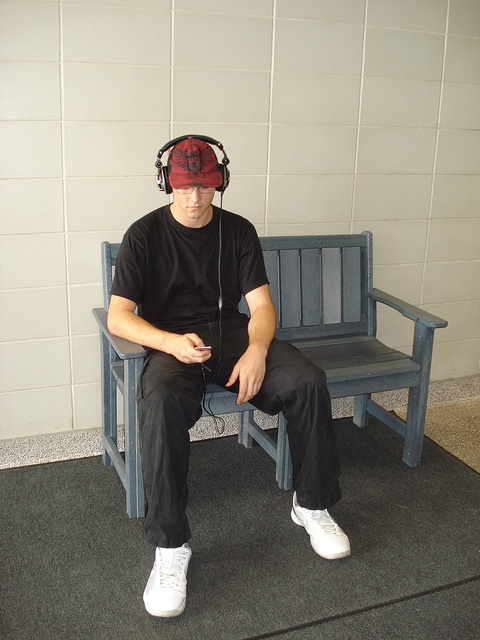Describe the objects in this image and their specific colors. I can see people in tan, black, white, and gray tones, bench in tan, gray, darkgray, black, and purple tones, and cell phone in tan, brown, lightgray, and salmon tones in this image. 